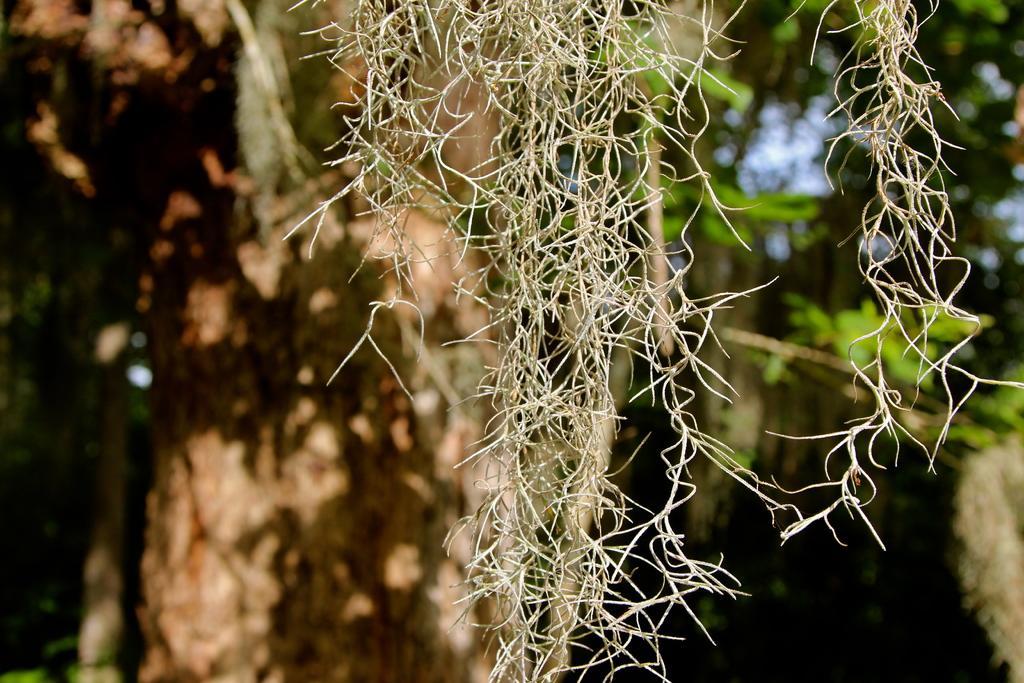Describe this image in one or two sentences. Here we can see a dried plant. Background it is blurry and we can see greenery. 